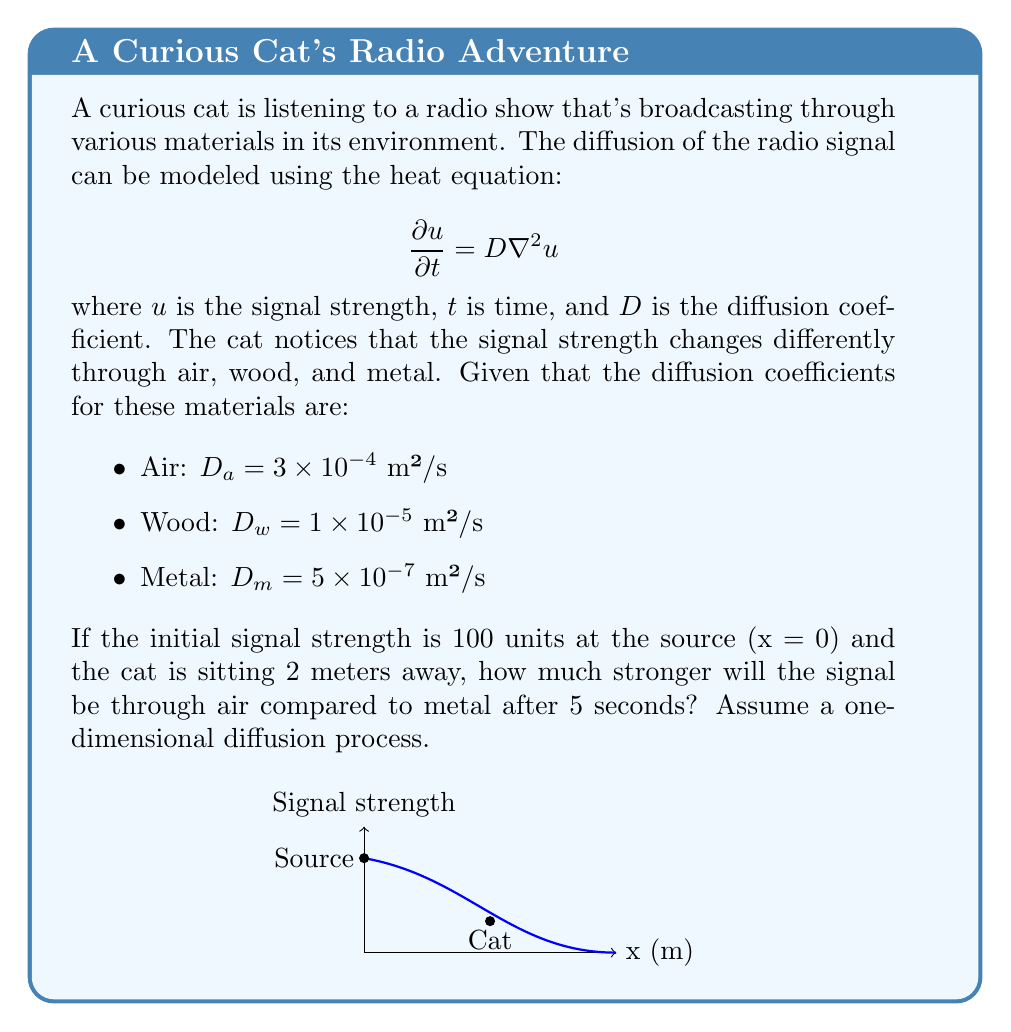Show me your answer to this math problem. To solve this problem, we'll use the one-dimensional solution to the heat equation:

$$u(x,t) = \frac{u_0}{\sqrt{4\pi Dt}} \exp\left(-\frac{x^2}{4Dt}\right)$$

where $u_0$ is the initial signal strength, $x$ is the distance, $t$ is time, and $D$ is the diffusion coefficient.

Step 1: Calculate the signal strength through air:
$$u_a(2,5) = \frac{100}{\sqrt{4\pi (3 \times 10^{-4})(5)}} \exp\left(-\frac{2^2}{4(3 \times 10^{-4})(5)}\right)$$

Step 2: Calculate the signal strength through metal:
$$u_m(2,5) = \frac{100}{\sqrt{4\pi (5 \times 10^{-7})(5)}} \exp\left(-\frac{2^2}{4(5 \times 10^{-7})(5)}\right)$$

Step 3: Evaluate both expressions:
$u_a(2,5) \approx 2.0598$ units
$u_m(2,5) \approx 1.5836 \times 10^{-434}$ units

Step 4: Calculate the ratio of signal strengths:
$$\frac{u_a(2,5)}{u_m(2,5)} \approx \frac{2.0598}{1.5836 \times 10^{-434}} \approx 1.3007 \times 10^{434}$$

The signal through air is approximately $1.3007 \times 10^{434}$ times stronger than through metal.
Answer: $1.3007 \times 10^{434}$ times stronger 